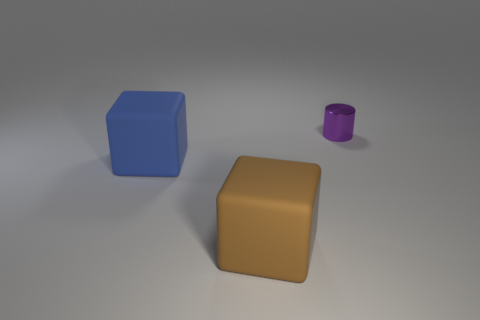What are the apparent materials of the objects displayed? The objects presented appear to be rendered with a matte finish. The blue and brown objects seem to simulate a solid plastic or painted wood, while the smaller item has a metallic sheen indicative of painted metal or plastic with a glossy finish. 